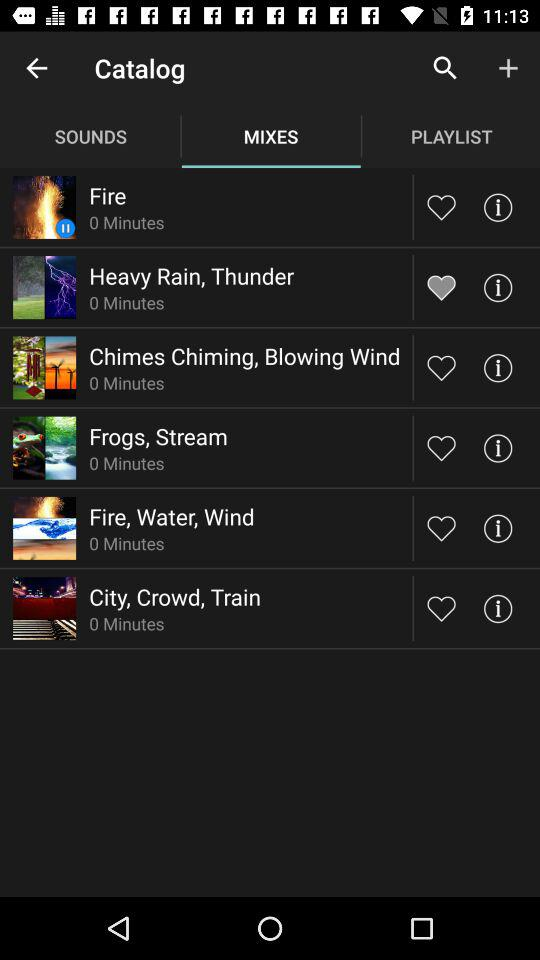Which tab is selected? The selected tab is "MIXES". 